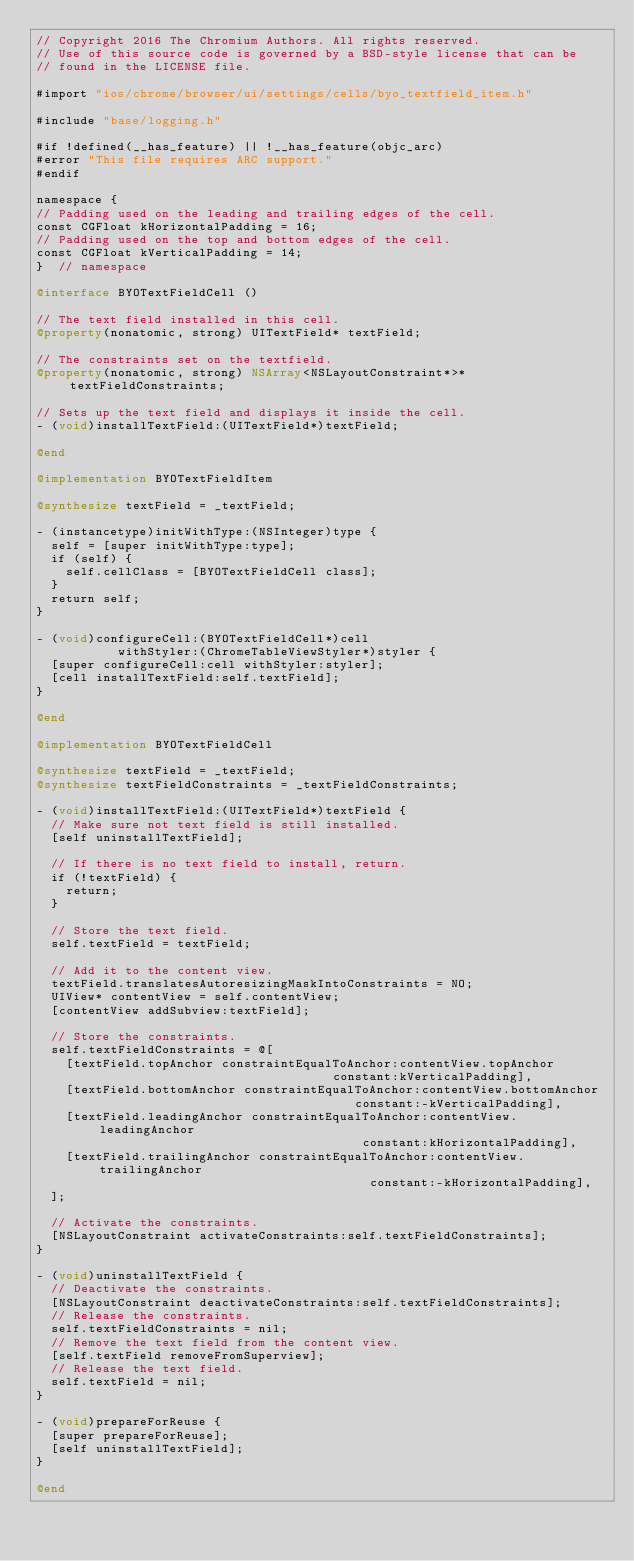<code> <loc_0><loc_0><loc_500><loc_500><_ObjectiveC_>// Copyright 2016 The Chromium Authors. All rights reserved.
// Use of this source code is governed by a BSD-style license that can be
// found in the LICENSE file.

#import "ios/chrome/browser/ui/settings/cells/byo_textfield_item.h"

#include "base/logging.h"

#if !defined(__has_feature) || !__has_feature(objc_arc)
#error "This file requires ARC support."
#endif

namespace {
// Padding used on the leading and trailing edges of the cell.
const CGFloat kHorizontalPadding = 16;
// Padding used on the top and bottom edges of the cell.
const CGFloat kVerticalPadding = 14;
}  // namespace

@interface BYOTextFieldCell ()

// The text field installed in this cell.
@property(nonatomic, strong) UITextField* textField;

// The constraints set on the textfield.
@property(nonatomic, strong) NSArray<NSLayoutConstraint*>* textFieldConstraints;

// Sets up the text field and displays it inside the cell.
- (void)installTextField:(UITextField*)textField;

@end

@implementation BYOTextFieldItem

@synthesize textField = _textField;

- (instancetype)initWithType:(NSInteger)type {
  self = [super initWithType:type];
  if (self) {
    self.cellClass = [BYOTextFieldCell class];
  }
  return self;
}

- (void)configureCell:(BYOTextFieldCell*)cell
           withStyler:(ChromeTableViewStyler*)styler {
  [super configureCell:cell withStyler:styler];
  [cell installTextField:self.textField];
}

@end

@implementation BYOTextFieldCell

@synthesize textField = _textField;
@synthesize textFieldConstraints = _textFieldConstraints;

- (void)installTextField:(UITextField*)textField {
  // Make sure not text field is still installed.
  [self uninstallTextField];

  // If there is no text field to install, return.
  if (!textField) {
    return;
  }

  // Store the text field.
  self.textField = textField;

  // Add it to the content view.
  textField.translatesAutoresizingMaskIntoConstraints = NO;
  UIView* contentView = self.contentView;
  [contentView addSubview:textField];

  // Store the constraints.
  self.textFieldConstraints = @[
    [textField.topAnchor constraintEqualToAnchor:contentView.topAnchor
                                        constant:kVerticalPadding],
    [textField.bottomAnchor constraintEqualToAnchor:contentView.bottomAnchor
                                           constant:-kVerticalPadding],
    [textField.leadingAnchor constraintEqualToAnchor:contentView.leadingAnchor
                                            constant:kHorizontalPadding],
    [textField.trailingAnchor constraintEqualToAnchor:contentView.trailingAnchor
                                             constant:-kHorizontalPadding],
  ];

  // Activate the constraints.
  [NSLayoutConstraint activateConstraints:self.textFieldConstraints];
}

- (void)uninstallTextField {
  // Deactivate the constraints.
  [NSLayoutConstraint deactivateConstraints:self.textFieldConstraints];
  // Release the constraints.
  self.textFieldConstraints = nil;
  // Remove the text field from the content view.
  [self.textField removeFromSuperview];
  // Release the text field.
  self.textField = nil;
}

- (void)prepareForReuse {
  [super prepareForReuse];
  [self uninstallTextField];
}

@end
</code> 